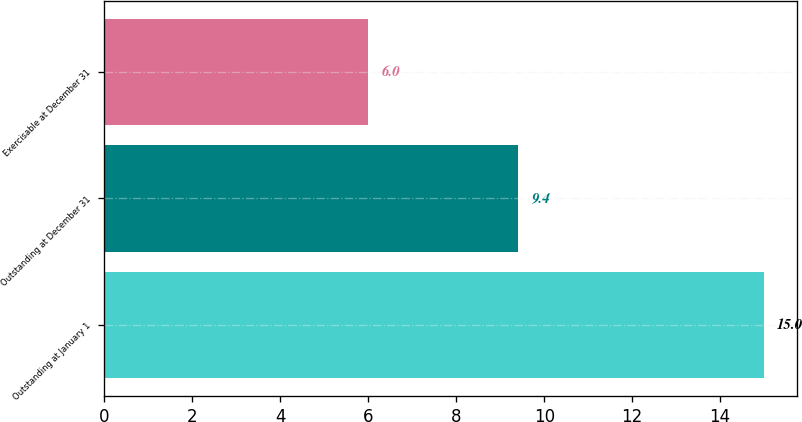<chart> <loc_0><loc_0><loc_500><loc_500><bar_chart><fcel>Outstanding at January 1<fcel>Outstanding at December 31<fcel>Exercisable at December 31<nl><fcel>15<fcel>9.4<fcel>6<nl></chart> 